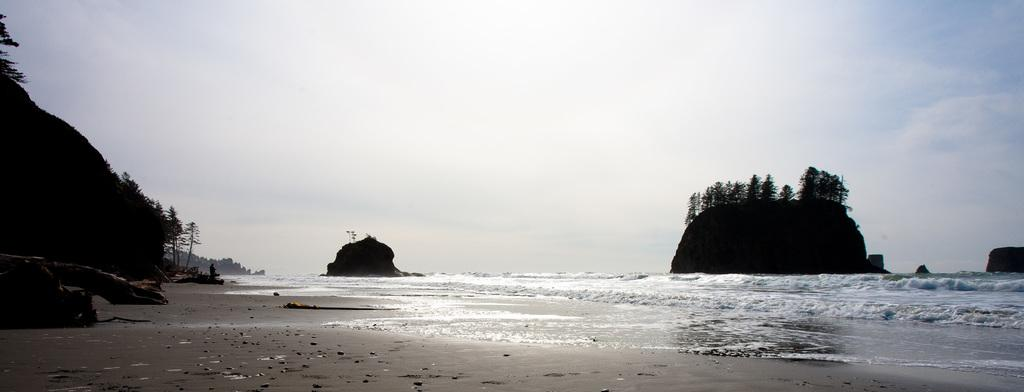What type of landscape is shown in the image? The image depicts a sea. What other geographical features can be seen in the image? There are mountains in the image. What kind of vegetation is present on the mountains? Trees are present on the mountains. What is visible at the top of the image? The sky is visible at the top of the image. What elements are visible at the bottom of the image? Water and sand are visible at the bottom of the image. What type of jelly is being used to create the mountains in the image? There is no jelly present in the image; the mountains are natural geographical features. What hobbies are the mountains engaged in within the image? Mountains are not capable of engaging in hobbies, as they are inanimate geographical features. 